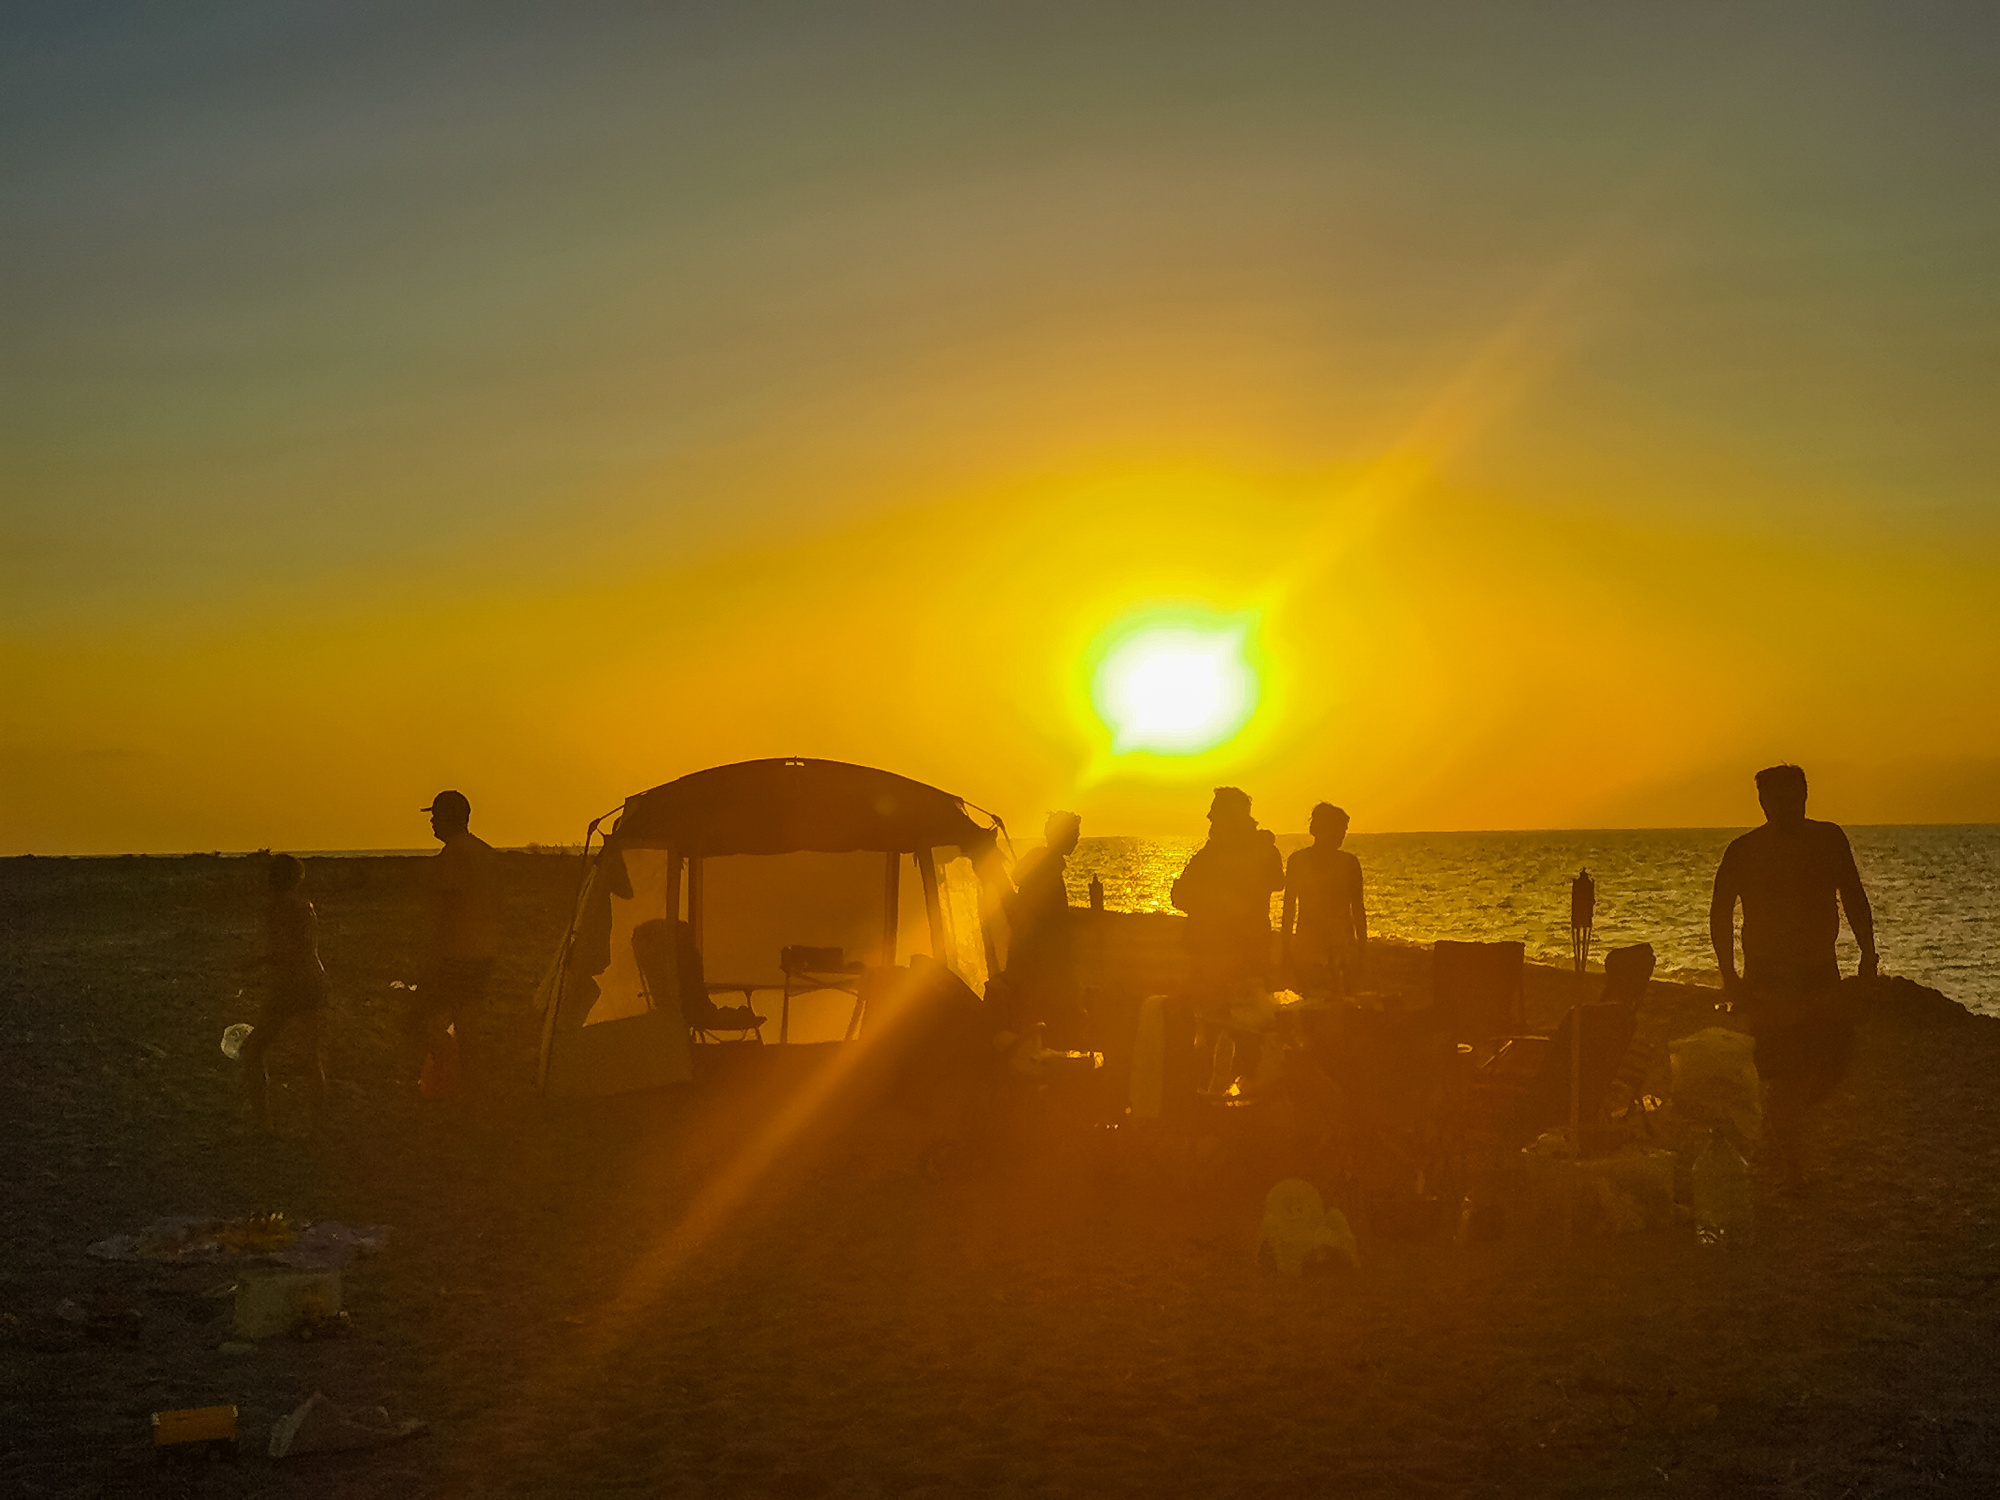Who might these people be and what activities could they have enjoyed today? The people gathered could be a mix of friends and families, linked by the desire to savor a day spent by the water. Given the variety of items such as beach chairs, toys, and a cooler, they likely engaged in classic seaside activities: building sandcastles, chasing waves, perhaps a game of beach volleyball or frisbee. As the sun retreats, so do they, taking with them memories saturated with sunlight and laughter. 